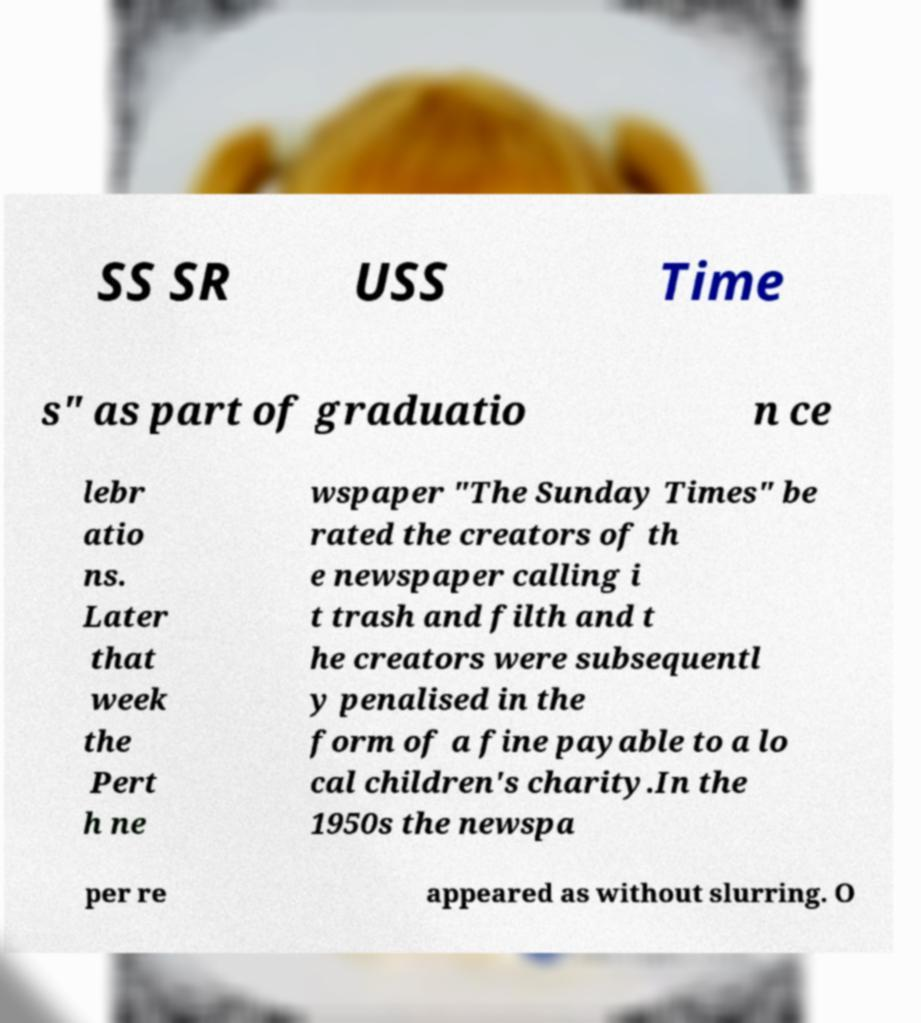There's text embedded in this image that I need extracted. Can you transcribe it verbatim? SS SR USS Time s" as part of graduatio n ce lebr atio ns. Later that week the Pert h ne wspaper "The Sunday Times" be rated the creators of th e newspaper calling i t trash and filth and t he creators were subsequentl y penalised in the form of a fine payable to a lo cal children's charity.In the 1950s the newspa per re appeared as without slurring. O 